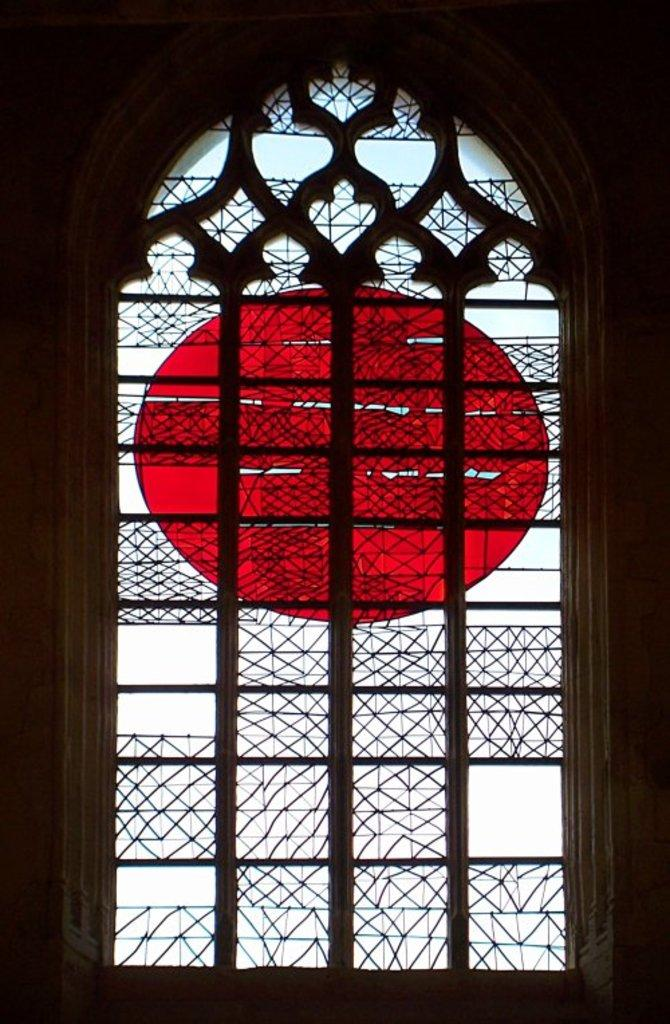What is one of the main features of the image? There is a wall in the image. What is depicted on the wall? There is a painting on glass in the image. Is there a gun visible in the painting on glass? There is no mention of a gun in the image or the painting on glass, so we cannot confirm its presence. 